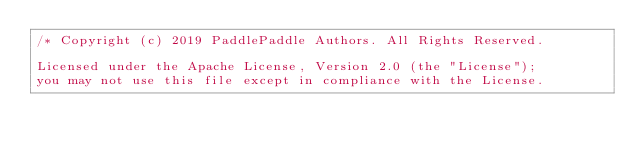<code> <loc_0><loc_0><loc_500><loc_500><_C++_>/* Copyright (c) 2019 PaddlePaddle Authors. All Rights Reserved.

Licensed under the Apache License, Version 2.0 (the "License");
you may not use this file except in compliance with the License.</code> 